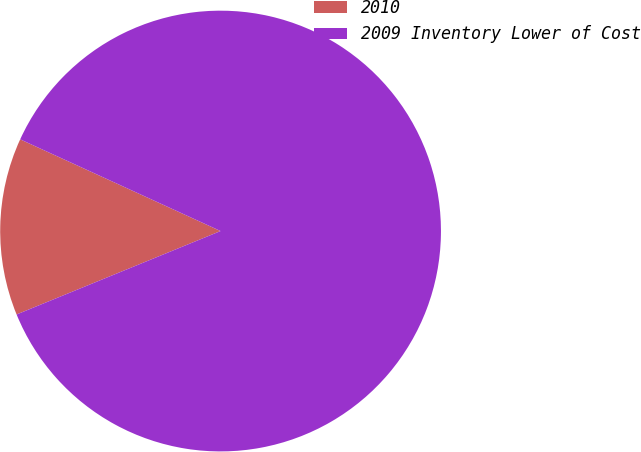Convert chart. <chart><loc_0><loc_0><loc_500><loc_500><pie_chart><fcel>2010<fcel>2009 Inventory Lower of Cost<nl><fcel>13.01%<fcel>86.99%<nl></chart> 